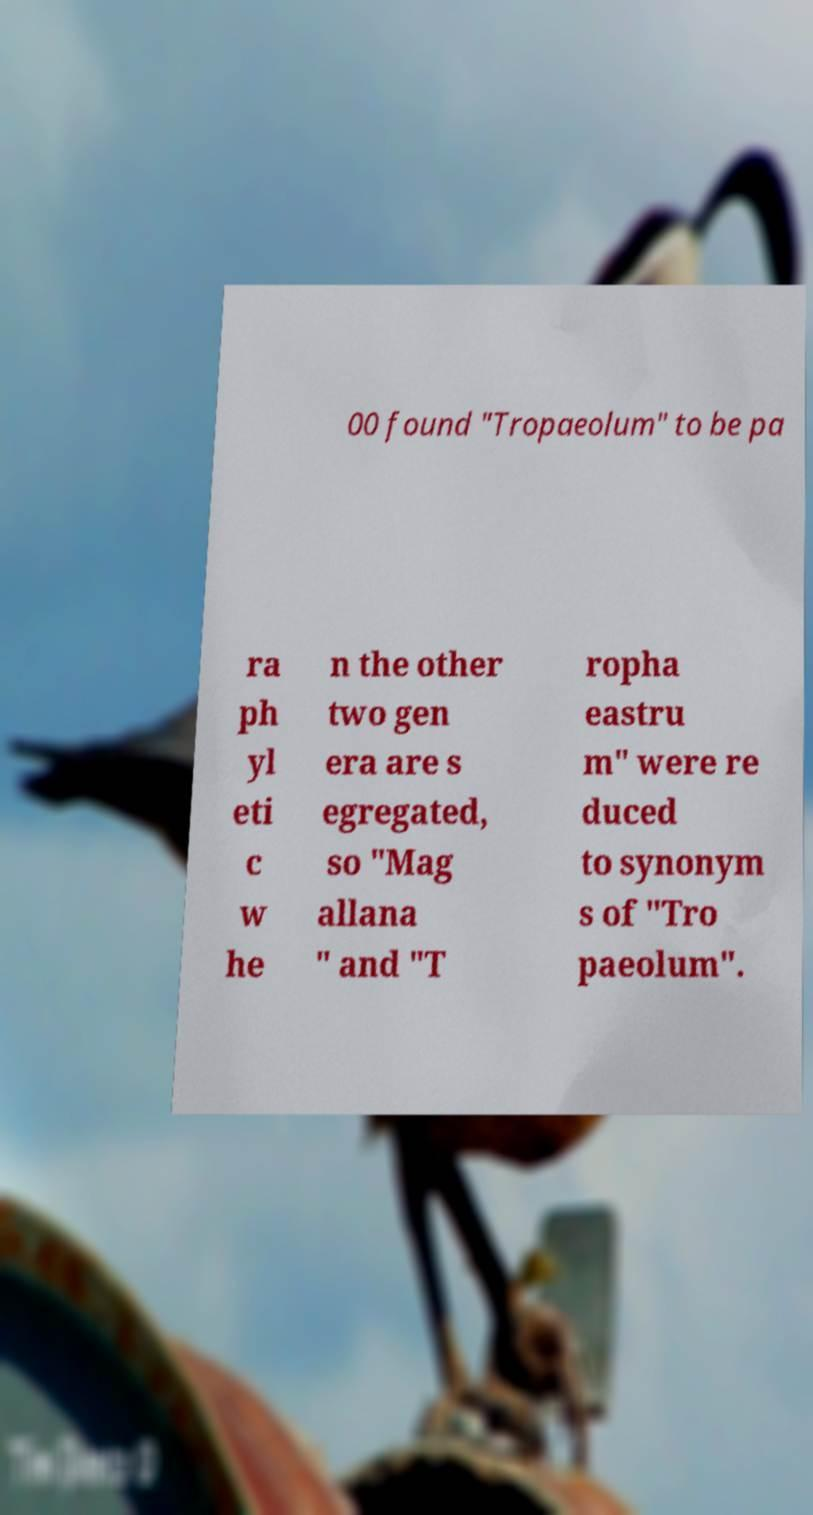Please read and relay the text visible in this image. What does it say? 00 found "Tropaeolum" to be pa ra ph yl eti c w he n the other two gen era are s egregated, so "Mag allana " and "T ropha eastru m" were re duced to synonym s of "Tro paeolum". 